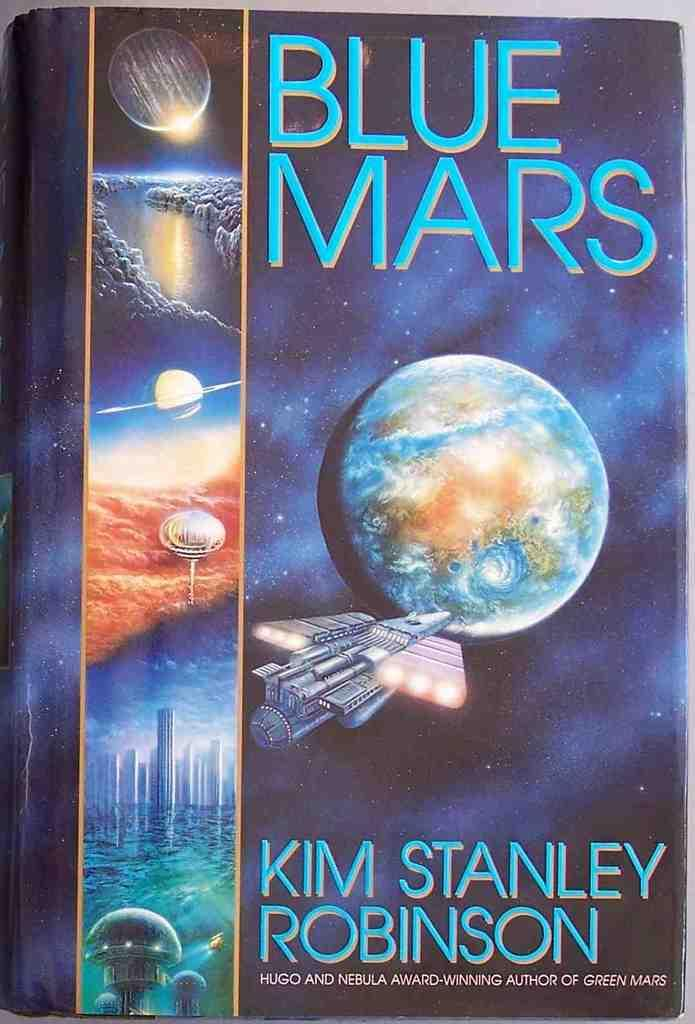<image>
Create a compact narrative representing the image presented. A book titled Blue Mars has a spaceship and planet on it. 